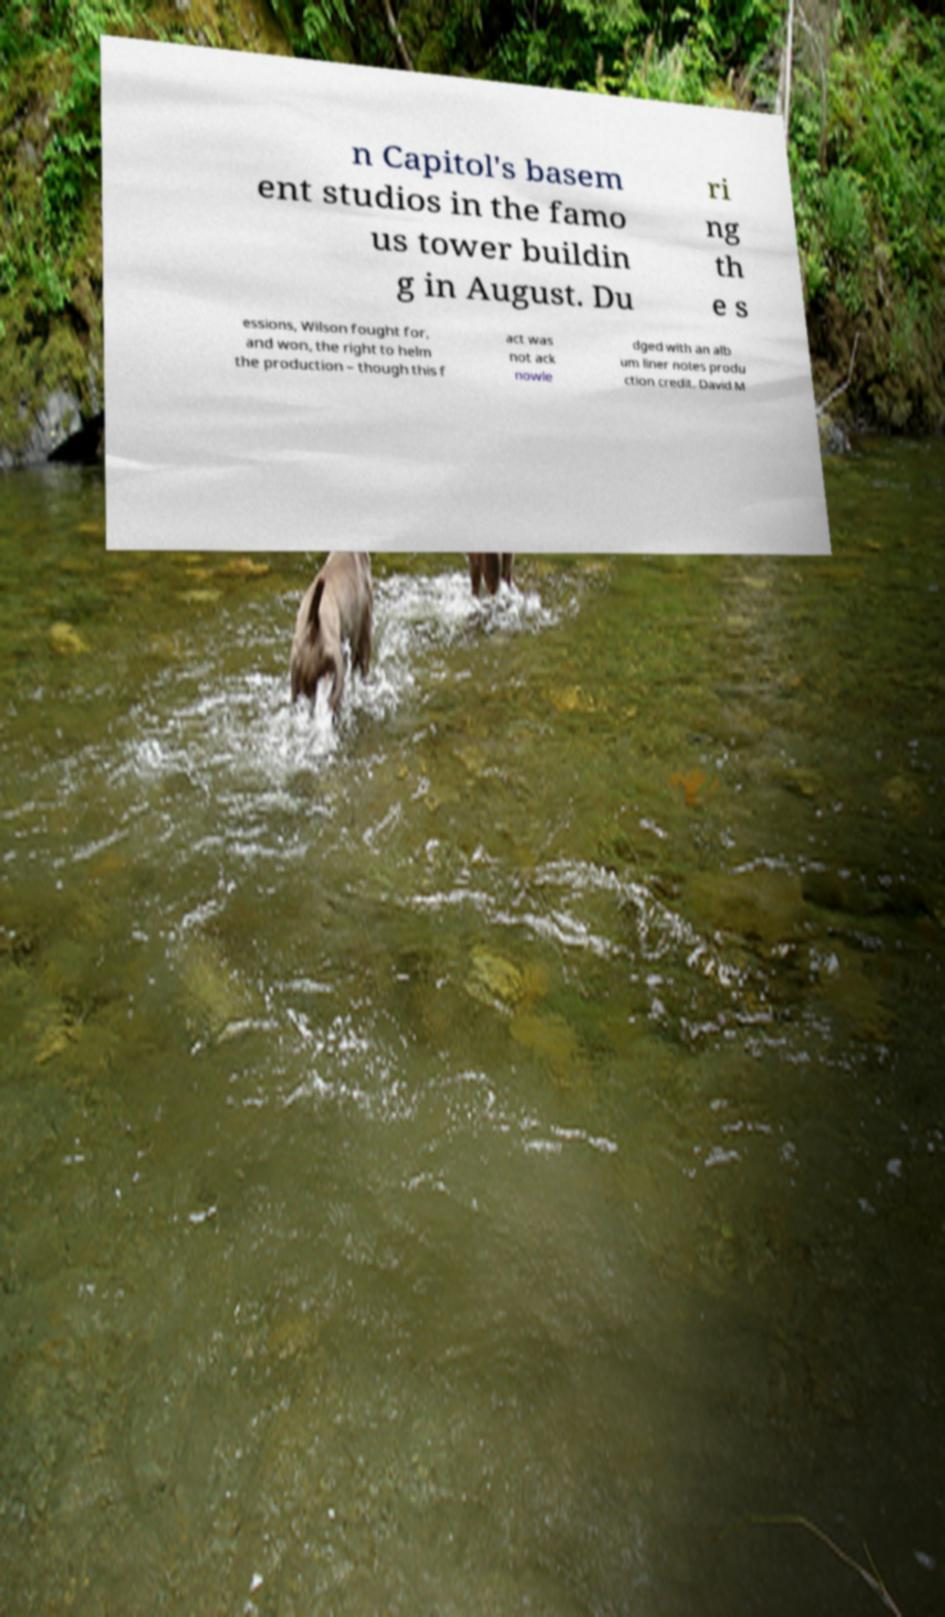Please read and relay the text visible in this image. What does it say? n Capitol's basem ent studios in the famo us tower buildin g in August. Du ri ng th e s essions, Wilson fought for, and won, the right to helm the production – though this f act was not ack nowle dged with an alb um liner notes produ ction credit. David M 